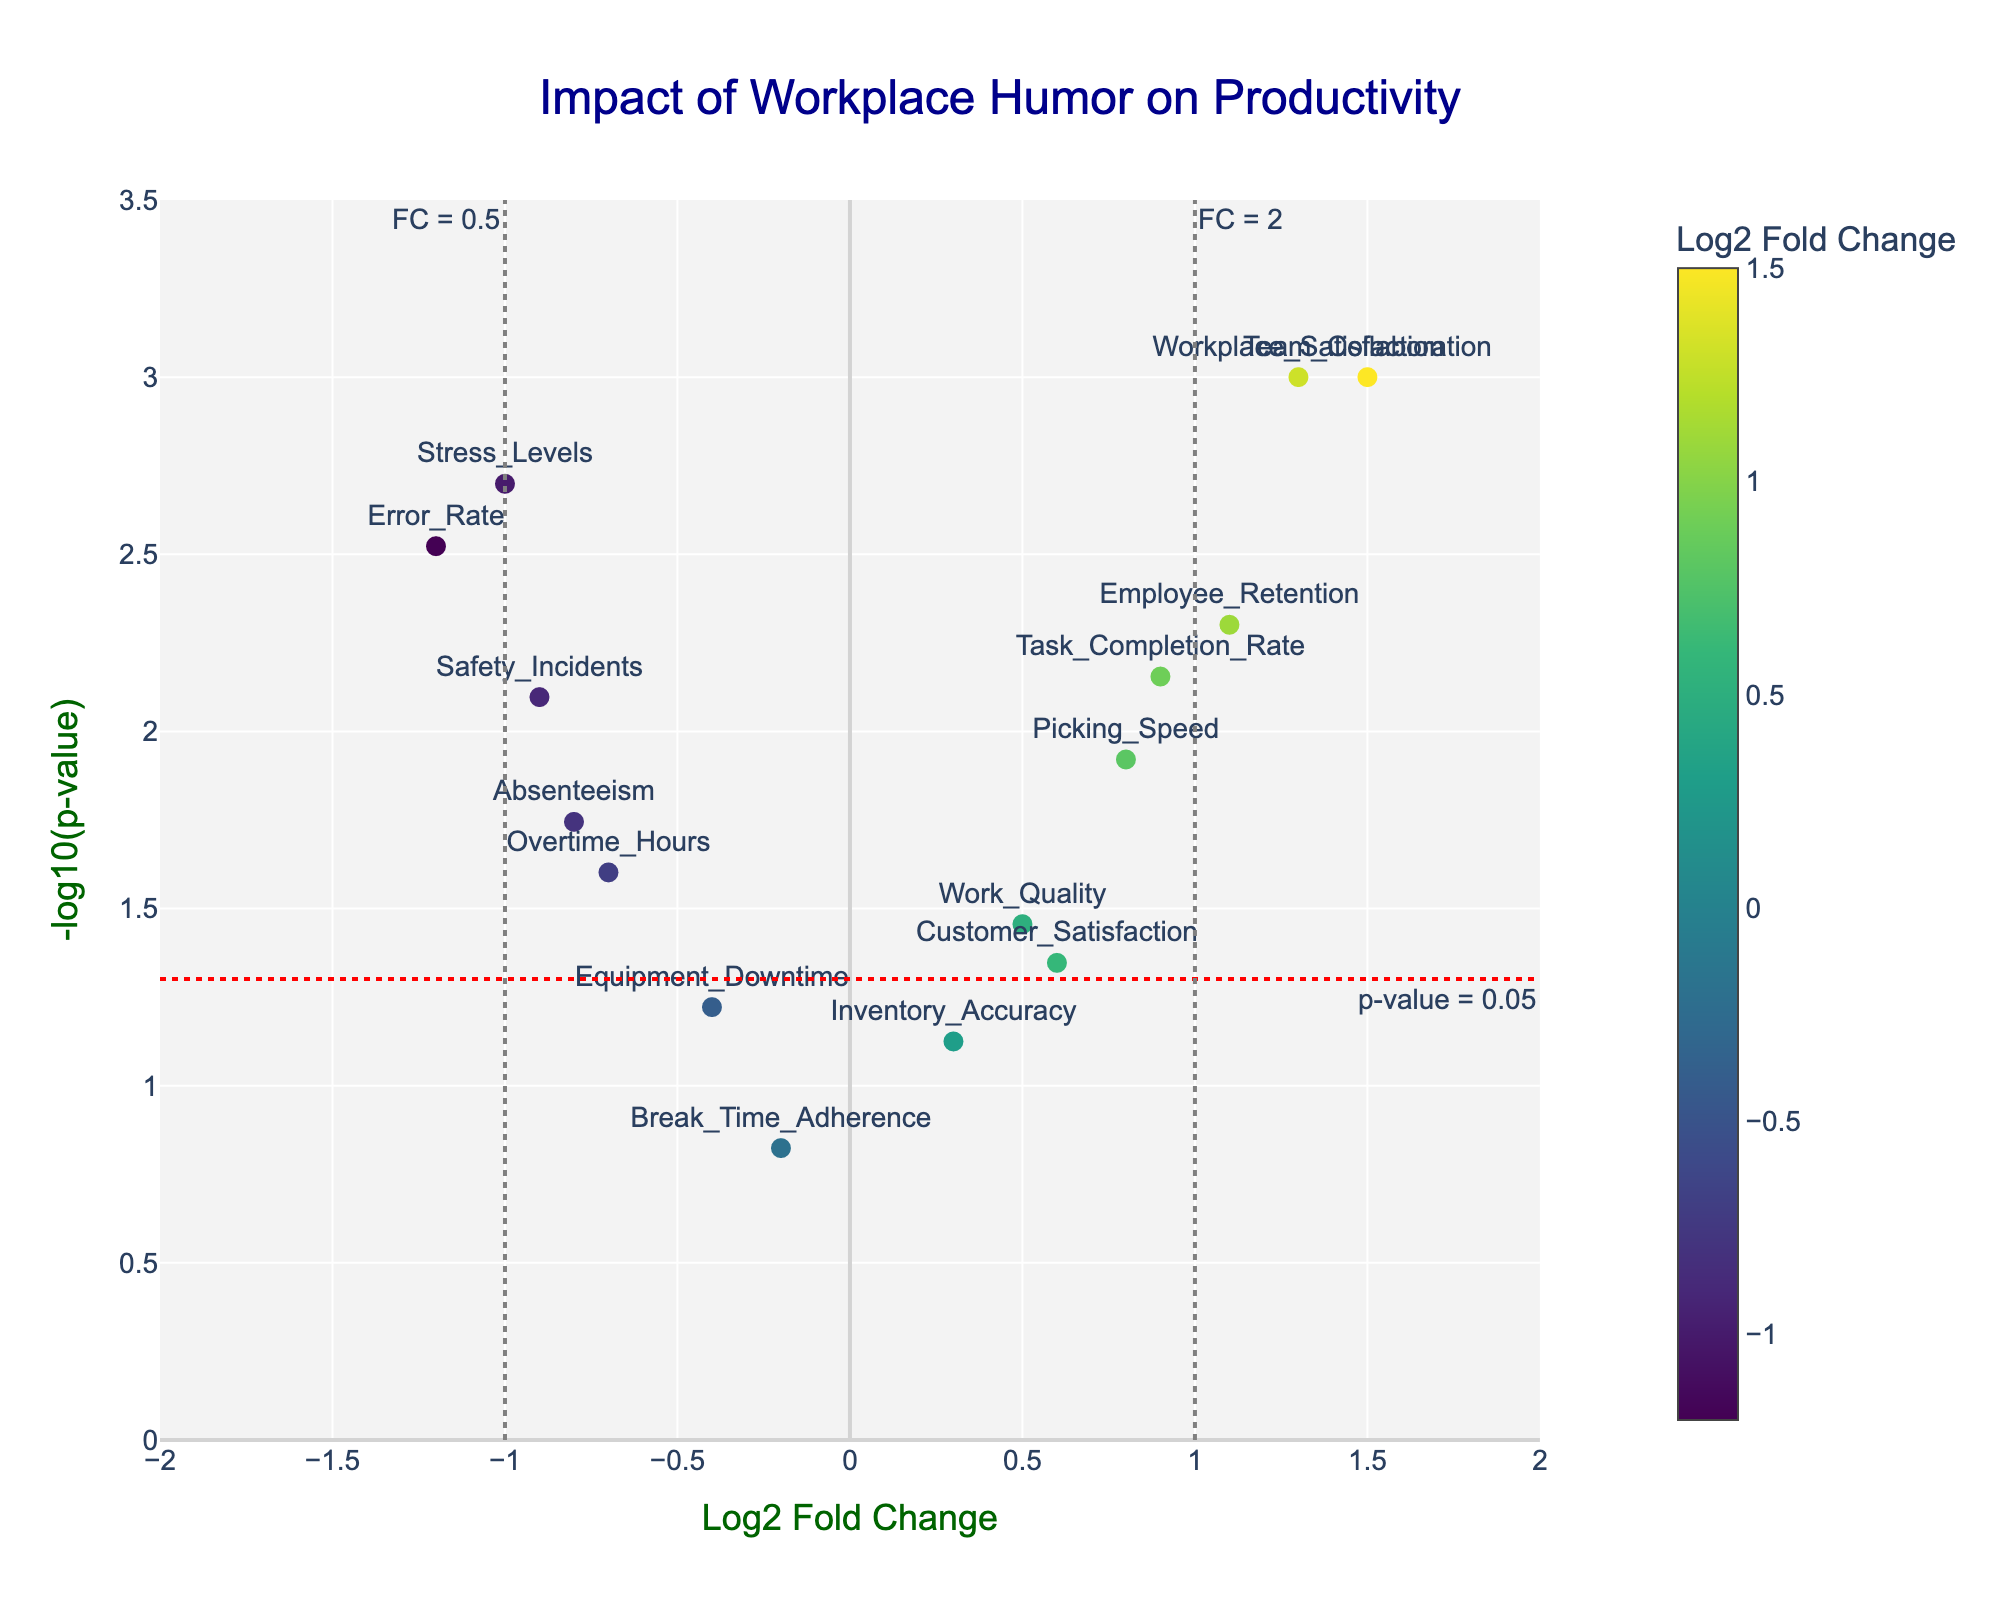Which metric has the highest fold change? The metric with the highest fold change is found by looking at the x-axis for the point furthest to the right. "Team Collaboration" is the point with the highest Log2 Fold Change at 1.5.
Answer: Team Collaboration Which metric shows the most significant p-value? The most significant p-value is identified by the point highest on the y-axis since -log10(p-value) increases as the p-value decreases. "Team Collaboration" is the highest point with a -log10(p-value) around 3.
Answer: Team Collaboration Are there any metrics with increased performance and a significant p-value (p < 0.05)? Increased performance metrics have positive Log2 Fold Change and significant p-values are those above the red dashed line. These metrics are "Team Collaboration", "Employee Retention", "Task Completion Rate", "Picking Speed", "Customer Satisfaction", and "Workplace Satisfaction".
Answer: Yes, there are six metrics Which metrics have negative impacts with p-values less than 0.05? Negative impacts are indicated by negative Log2 Fold Change. Those below the red dashed line are significant. These metrics are "Error Rate", "Safety Incidents", "Stress Levels", "Overtime Hours", "Absenteeism".
Answer: Error Rate, Safety Incidents, Stress Levels, Overtime Hours, Absenteeism Which metric has a fold change closest to zero but is still significant? The metric closest to zero on the x-axis, but above the red dashed line for significance, is "Overtime Hours" with a Log2 Fold Change of -0.7.
Answer: Overtime Hours What is the -log10(p-value) for Safety Incidents? Locate "Safety Incidents" on the plot, then read the y-axis value. The -log10(p-value) for Safety Incidents is approximately 2.1.
Answer: Approximately 2.1 Compare the fold change of Picking Speed and Customer Satisfaction. Which has higher fold change? Compare the x-axis values of "Picking Speed" and "Customer Satisfaction". "Picking Speed" has a Log2 Fold Change of 0.8, while "Customer Satisfaction" has 0.6. Picking Speed has a higher fold change.
Answer: Picking Speed How many metrics exhibit both a significant p-value (p < 0.05) and positive impact? Count the data points above the red dashed line with positive x-axis values. These metrics are "Team Collaboration", "Employee Retention", "Task Completion Rate", "Picking Speed", "Customer Satisfaction", and "Workplace Satisfaction". There are six in total.
Answer: Six metrics Does Break Time Adherence show significant changes due to workplace humor? Check the location of "Break Time Adherence" on the plot. It is below the red dashed line, indicating a p-value > 0.05, hence not significant.
Answer: No Which metric has the largest negative fold change and what is its p-value? Look for the metric furthest to the left on the x-axis. "Error Rate" is the metric with the largest negative fold change at -1.2. Its p-value is 0.003.
Answer: Error Rate, 0.003 